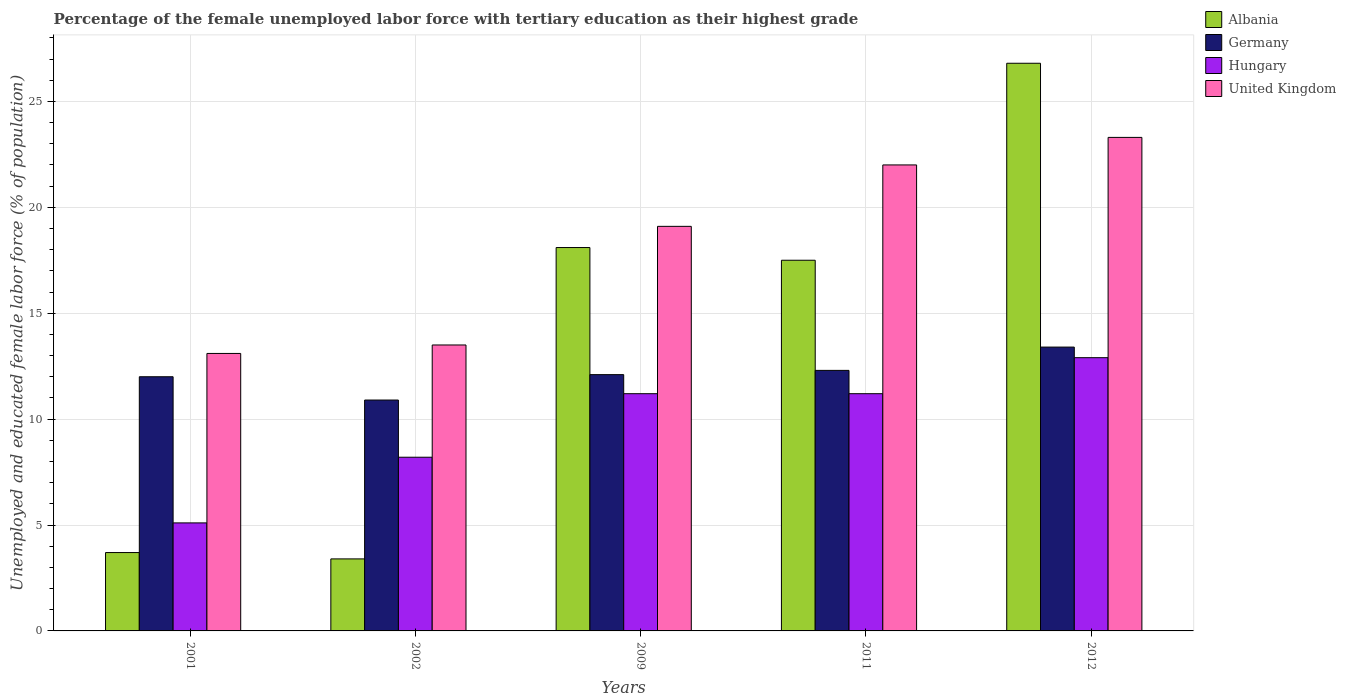How many different coloured bars are there?
Give a very brief answer. 4. How many groups of bars are there?
Your response must be concise. 5. Are the number of bars per tick equal to the number of legend labels?
Keep it short and to the point. Yes. Are the number of bars on each tick of the X-axis equal?
Your response must be concise. Yes. How many bars are there on the 3rd tick from the left?
Your answer should be compact. 4. How many bars are there on the 1st tick from the right?
Offer a terse response. 4. In how many cases, is the number of bars for a given year not equal to the number of legend labels?
Your answer should be very brief. 0. What is the percentage of the unemployed female labor force with tertiary education in Germany in 2001?
Ensure brevity in your answer.  12. Across all years, what is the maximum percentage of the unemployed female labor force with tertiary education in Germany?
Your answer should be very brief. 13.4. Across all years, what is the minimum percentage of the unemployed female labor force with tertiary education in Hungary?
Provide a succinct answer. 5.1. In which year was the percentage of the unemployed female labor force with tertiary education in Albania minimum?
Make the answer very short. 2002. What is the total percentage of the unemployed female labor force with tertiary education in United Kingdom in the graph?
Provide a succinct answer. 91. What is the difference between the percentage of the unemployed female labor force with tertiary education in Hungary in 2011 and that in 2012?
Offer a very short reply. -1.7. What is the difference between the percentage of the unemployed female labor force with tertiary education in Hungary in 2011 and the percentage of the unemployed female labor force with tertiary education in Germany in 2001?
Keep it short and to the point. -0.8. What is the average percentage of the unemployed female labor force with tertiary education in Hungary per year?
Provide a succinct answer. 9.72. In the year 2011, what is the difference between the percentage of the unemployed female labor force with tertiary education in Hungary and percentage of the unemployed female labor force with tertiary education in United Kingdom?
Offer a terse response. -10.8. What is the ratio of the percentage of the unemployed female labor force with tertiary education in United Kingdom in 2009 to that in 2012?
Your answer should be very brief. 0.82. Is the difference between the percentage of the unemployed female labor force with tertiary education in Hungary in 2001 and 2009 greater than the difference between the percentage of the unemployed female labor force with tertiary education in United Kingdom in 2001 and 2009?
Your answer should be compact. No. What is the difference between the highest and the second highest percentage of the unemployed female labor force with tertiary education in Hungary?
Make the answer very short. 1.7. What is the difference between the highest and the lowest percentage of the unemployed female labor force with tertiary education in Hungary?
Your answer should be very brief. 7.8. Is the sum of the percentage of the unemployed female labor force with tertiary education in Germany in 2001 and 2012 greater than the maximum percentage of the unemployed female labor force with tertiary education in United Kingdom across all years?
Your answer should be very brief. Yes. Is it the case that in every year, the sum of the percentage of the unemployed female labor force with tertiary education in Albania and percentage of the unemployed female labor force with tertiary education in Hungary is greater than the sum of percentage of the unemployed female labor force with tertiary education in United Kingdom and percentage of the unemployed female labor force with tertiary education in Germany?
Provide a succinct answer. No. What does the 3rd bar from the left in 2012 represents?
Keep it short and to the point. Hungary. What does the 2nd bar from the right in 2002 represents?
Offer a very short reply. Hungary. Are the values on the major ticks of Y-axis written in scientific E-notation?
Give a very brief answer. No. Where does the legend appear in the graph?
Keep it short and to the point. Top right. How many legend labels are there?
Provide a succinct answer. 4. What is the title of the graph?
Provide a succinct answer. Percentage of the female unemployed labor force with tertiary education as their highest grade. Does "Netherlands" appear as one of the legend labels in the graph?
Keep it short and to the point. No. What is the label or title of the Y-axis?
Give a very brief answer. Unemployed and educated female labor force (% of population). What is the Unemployed and educated female labor force (% of population) of Albania in 2001?
Ensure brevity in your answer.  3.7. What is the Unemployed and educated female labor force (% of population) of Germany in 2001?
Keep it short and to the point. 12. What is the Unemployed and educated female labor force (% of population) of Hungary in 2001?
Give a very brief answer. 5.1. What is the Unemployed and educated female labor force (% of population) in United Kingdom in 2001?
Provide a succinct answer. 13.1. What is the Unemployed and educated female labor force (% of population) of Albania in 2002?
Keep it short and to the point. 3.4. What is the Unemployed and educated female labor force (% of population) of Germany in 2002?
Offer a terse response. 10.9. What is the Unemployed and educated female labor force (% of population) of Hungary in 2002?
Provide a short and direct response. 8.2. What is the Unemployed and educated female labor force (% of population) in Albania in 2009?
Your answer should be compact. 18.1. What is the Unemployed and educated female labor force (% of population) of Germany in 2009?
Make the answer very short. 12.1. What is the Unemployed and educated female labor force (% of population) in Hungary in 2009?
Your answer should be compact. 11.2. What is the Unemployed and educated female labor force (% of population) in United Kingdom in 2009?
Your response must be concise. 19.1. What is the Unemployed and educated female labor force (% of population) of Germany in 2011?
Your response must be concise. 12.3. What is the Unemployed and educated female labor force (% of population) of Hungary in 2011?
Keep it short and to the point. 11.2. What is the Unemployed and educated female labor force (% of population) of United Kingdom in 2011?
Your response must be concise. 22. What is the Unemployed and educated female labor force (% of population) in Albania in 2012?
Provide a short and direct response. 26.8. What is the Unemployed and educated female labor force (% of population) of Germany in 2012?
Offer a very short reply. 13.4. What is the Unemployed and educated female labor force (% of population) of Hungary in 2012?
Your answer should be compact. 12.9. What is the Unemployed and educated female labor force (% of population) of United Kingdom in 2012?
Your response must be concise. 23.3. Across all years, what is the maximum Unemployed and educated female labor force (% of population) in Albania?
Ensure brevity in your answer.  26.8. Across all years, what is the maximum Unemployed and educated female labor force (% of population) in Germany?
Offer a very short reply. 13.4. Across all years, what is the maximum Unemployed and educated female labor force (% of population) in Hungary?
Offer a very short reply. 12.9. Across all years, what is the maximum Unemployed and educated female labor force (% of population) in United Kingdom?
Provide a short and direct response. 23.3. Across all years, what is the minimum Unemployed and educated female labor force (% of population) in Albania?
Ensure brevity in your answer.  3.4. Across all years, what is the minimum Unemployed and educated female labor force (% of population) in Germany?
Ensure brevity in your answer.  10.9. Across all years, what is the minimum Unemployed and educated female labor force (% of population) of Hungary?
Offer a terse response. 5.1. Across all years, what is the minimum Unemployed and educated female labor force (% of population) in United Kingdom?
Make the answer very short. 13.1. What is the total Unemployed and educated female labor force (% of population) in Albania in the graph?
Your answer should be very brief. 69.5. What is the total Unemployed and educated female labor force (% of population) in Germany in the graph?
Provide a short and direct response. 60.7. What is the total Unemployed and educated female labor force (% of population) in Hungary in the graph?
Make the answer very short. 48.6. What is the total Unemployed and educated female labor force (% of population) in United Kingdom in the graph?
Provide a short and direct response. 91. What is the difference between the Unemployed and educated female labor force (% of population) in Albania in 2001 and that in 2002?
Provide a succinct answer. 0.3. What is the difference between the Unemployed and educated female labor force (% of population) of Germany in 2001 and that in 2002?
Provide a succinct answer. 1.1. What is the difference between the Unemployed and educated female labor force (% of population) of United Kingdom in 2001 and that in 2002?
Give a very brief answer. -0.4. What is the difference between the Unemployed and educated female labor force (% of population) in Albania in 2001 and that in 2009?
Keep it short and to the point. -14.4. What is the difference between the Unemployed and educated female labor force (% of population) in Hungary in 2001 and that in 2009?
Ensure brevity in your answer.  -6.1. What is the difference between the Unemployed and educated female labor force (% of population) in United Kingdom in 2001 and that in 2009?
Ensure brevity in your answer.  -6. What is the difference between the Unemployed and educated female labor force (% of population) of Albania in 2001 and that in 2012?
Keep it short and to the point. -23.1. What is the difference between the Unemployed and educated female labor force (% of population) of Germany in 2001 and that in 2012?
Offer a very short reply. -1.4. What is the difference between the Unemployed and educated female labor force (% of population) of Albania in 2002 and that in 2009?
Ensure brevity in your answer.  -14.7. What is the difference between the Unemployed and educated female labor force (% of population) of Germany in 2002 and that in 2009?
Offer a very short reply. -1.2. What is the difference between the Unemployed and educated female labor force (% of population) of United Kingdom in 2002 and that in 2009?
Your response must be concise. -5.6. What is the difference between the Unemployed and educated female labor force (% of population) in Albania in 2002 and that in 2011?
Ensure brevity in your answer.  -14.1. What is the difference between the Unemployed and educated female labor force (% of population) in Hungary in 2002 and that in 2011?
Offer a terse response. -3. What is the difference between the Unemployed and educated female labor force (% of population) of United Kingdom in 2002 and that in 2011?
Your answer should be very brief. -8.5. What is the difference between the Unemployed and educated female labor force (% of population) in Albania in 2002 and that in 2012?
Give a very brief answer. -23.4. What is the difference between the Unemployed and educated female labor force (% of population) of Hungary in 2009 and that in 2011?
Make the answer very short. 0. What is the difference between the Unemployed and educated female labor force (% of population) in United Kingdom in 2009 and that in 2011?
Provide a succinct answer. -2.9. What is the difference between the Unemployed and educated female labor force (% of population) of Albania in 2009 and that in 2012?
Your answer should be compact. -8.7. What is the difference between the Unemployed and educated female labor force (% of population) of Germany in 2009 and that in 2012?
Keep it short and to the point. -1.3. What is the difference between the Unemployed and educated female labor force (% of population) in Hungary in 2009 and that in 2012?
Keep it short and to the point. -1.7. What is the difference between the Unemployed and educated female labor force (% of population) in Albania in 2011 and that in 2012?
Your response must be concise. -9.3. What is the difference between the Unemployed and educated female labor force (% of population) in United Kingdom in 2011 and that in 2012?
Offer a terse response. -1.3. What is the difference between the Unemployed and educated female labor force (% of population) of Albania in 2001 and the Unemployed and educated female labor force (% of population) of Hungary in 2002?
Offer a very short reply. -4.5. What is the difference between the Unemployed and educated female labor force (% of population) in Albania in 2001 and the Unemployed and educated female labor force (% of population) in United Kingdom in 2002?
Your answer should be compact. -9.8. What is the difference between the Unemployed and educated female labor force (% of population) of Germany in 2001 and the Unemployed and educated female labor force (% of population) of Hungary in 2002?
Provide a succinct answer. 3.8. What is the difference between the Unemployed and educated female labor force (% of population) in Germany in 2001 and the Unemployed and educated female labor force (% of population) in United Kingdom in 2002?
Offer a very short reply. -1.5. What is the difference between the Unemployed and educated female labor force (% of population) of Albania in 2001 and the Unemployed and educated female labor force (% of population) of United Kingdom in 2009?
Provide a short and direct response. -15.4. What is the difference between the Unemployed and educated female labor force (% of population) of Hungary in 2001 and the Unemployed and educated female labor force (% of population) of United Kingdom in 2009?
Your answer should be compact. -14. What is the difference between the Unemployed and educated female labor force (% of population) of Albania in 2001 and the Unemployed and educated female labor force (% of population) of Germany in 2011?
Your answer should be compact. -8.6. What is the difference between the Unemployed and educated female labor force (% of population) of Albania in 2001 and the Unemployed and educated female labor force (% of population) of United Kingdom in 2011?
Your answer should be very brief. -18.3. What is the difference between the Unemployed and educated female labor force (% of population) in Germany in 2001 and the Unemployed and educated female labor force (% of population) in United Kingdom in 2011?
Make the answer very short. -10. What is the difference between the Unemployed and educated female labor force (% of population) of Hungary in 2001 and the Unemployed and educated female labor force (% of population) of United Kingdom in 2011?
Your response must be concise. -16.9. What is the difference between the Unemployed and educated female labor force (% of population) of Albania in 2001 and the Unemployed and educated female labor force (% of population) of Hungary in 2012?
Your answer should be compact. -9.2. What is the difference between the Unemployed and educated female labor force (% of population) of Albania in 2001 and the Unemployed and educated female labor force (% of population) of United Kingdom in 2012?
Your answer should be very brief. -19.6. What is the difference between the Unemployed and educated female labor force (% of population) in Germany in 2001 and the Unemployed and educated female labor force (% of population) in United Kingdom in 2012?
Provide a short and direct response. -11.3. What is the difference between the Unemployed and educated female labor force (% of population) in Hungary in 2001 and the Unemployed and educated female labor force (% of population) in United Kingdom in 2012?
Your answer should be very brief. -18.2. What is the difference between the Unemployed and educated female labor force (% of population) of Albania in 2002 and the Unemployed and educated female labor force (% of population) of United Kingdom in 2009?
Provide a short and direct response. -15.7. What is the difference between the Unemployed and educated female labor force (% of population) of Germany in 2002 and the Unemployed and educated female labor force (% of population) of Hungary in 2009?
Make the answer very short. -0.3. What is the difference between the Unemployed and educated female labor force (% of population) of Germany in 2002 and the Unemployed and educated female labor force (% of population) of United Kingdom in 2009?
Make the answer very short. -8.2. What is the difference between the Unemployed and educated female labor force (% of population) of Albania in 2002 and the Unemployed and educated female labor force (% of population) of Germany in 2011?
Offer a terse response. -8.9. What is the difference between the Unemployed and educated female labor force (% of population) in Albania in 2002 and the Unemployed and educated female labor force (% of population) in United Kingdom in 2011?
Give a very brief answer. -18.6. What is the difference between the Unemployed and educated female labor force (% of population) in Germany in 2002 and the Unemployed and educated female labor force (% of population) in Hungary in 2011?
Keep it short and to the point. -0.3. What is the difference between the Unemployed and educated female labor force (% of population) of Germany in 2002 and the Unemployed and educated female labor force (% of population) of United Kingdom in 2011?
Give a very brief answer. -11.1. What is the difference between the Unemployed and educated female labor force (% of population) in Albania in 2002 and the Unemployed and educated female labor force (% of population) in Germany in 2012?
Offer a terse response. -10. What is the difference between the Unemployed and educated female labor force (% of population) of Albania in 2002 and the Unemployed and educated female labor force (% of population) of United Kingdom in 2012?
Provide a succinct answer. -19.9. What is the difference between the Unemployed and educated female labor force (% of population) in Germany in 2002 and the Unemployed and educated female labor force (% of population) in Hungary in 2012?
Keep it short and to the point. -2. What is the difference between the Unemployed and educated female labor force (% of population) of Germany in 2002 and the Unemployed and educated female labor force (% of population) of United Kingdom in 2012?
Your answer should be compact. -12.4. What is the difference between the Unemployed and educated female labor force (% of population) of Hungary in 2002 and the Unemployed and educated female labor force (% of population) of United Kingdom in 2012?
Offer a very short reply. -15.1. What is the difference between the Unemployed and educated female labor force (% of population) of Albania in 2009 and the Unemployed and educated female labor force (% of population) of Germany in 2011?
Keep it short and to the point. 5.8. What is the difference between the Unemployed and educated female labor force (% of population) of Albania in 2009 and the Unemployed and educated female labor force (% of population) of Hungary in 2011?
Ensure brevity in your answer.  6.9. What is the difference between the Unemployed and educated female labor force (% of population) in Albania in 2009 and the Unemployed and educated female labor force (% of population) in United Kingdom in 2011?
Provide a short and direct response. -3.9. What is the difference between the Unemployed and educated female labor force (% of population) of Albania in 2009 and the Unemployed and educated female labor force (% of population) of Germany in 2012?
Your answer should be very brief. 4.7. What is the difference between the Unemployed and educated female labor force (% of population) of Albania in 2009 and the Unemployed and educated female labor force (% of population) of Hungary in 2012?
Provide a succinct answer. 5.2. What is the difference between the Unemployed and educated female labor force (% of population) in Germany in 2011 and the Unemployed and educated female labor force (% of population) in Hungary in 2012?
Make the answer very short. -0.6. What is the difference between the Unemployed and educated female labor force (% of population) of Germany in 2011 and the Unemployed and educated female labor force (% of population) of United Kingdom in 2012?
Offer a terse response. -11. What is the difference between the Unemployed and educated female labor force (% of population) in Hungary in 2011 and the Unemployed and educated female labor force (% of population) in United Kingdom in 2012?
Provide a short and direct response. -12.1. What is the average Unemployed and educated female labor force (% of population) of Germany per year?
Your answer should be compact. 12.14. What is the average Unemployed and educated female labor force (% of population) of Hungary per year?
Make the answer very short. 9.72. What is the average Unemployed and educated female labor force (% of population) of United Kingdom per year?
Provide a succinct answer. 18.2. In the year 2001, what is the difference between the Unemployed and educated female labor force (% of population) in Albania and Unemployed and educated female labor force (% of population) in Hungary?
Your response must be concise. -1.4. In the year 2001, what is the difference between the Unemployed and educated female labor force (% of population) in Albania and Unemployed and educated female labor force (% of population) in United Kingdom?
Offer a very short reply. -9.4. In the year 2001, what is the difference between the Unemployed and educated female labor force (% of population) of Germany and Unemployed and educated female labor force (% of population) of Hungary?
Your answer should be very brief. 6.9. In the year 2001, what is the difference between the Unemployed and educated female labor force (% of population) of Germany and Unemployed and educated female labor force (% of population) of United Kingdom?
Your response must be concise. -1.1. In the year 2002, what is the difference between the Unemployed and educated female labor force (% of population) in Albania and Unemployed and educated female labor force (% of population) in Germany?
Your answer should be compact. -7.5. In the year 2002, what is the difference between the Unemployed and educated female labor force (% of population) in Albania and Unemployed and educated female labor force (% of population) in Hungary?
Provide a short and direct response. -4.8. In the year 2002, what is the difference between the Unemployed and educated female labor force (% of population) of Germany and Unemployed and educated female labor force (% of population) of Hungary?
Your answer should be very brief. 2.7. In the year 2002, what is the difference between the Unemployed and educated female labor force (% of population) of Germany and Unemployed and educated female labor force (% of population) of United Kingdom?
Your answer should be very brief. -2.6. In the year 2009, what is the difference between the Unemployed and educated female labor force (% of population) of Albania and Unemployed and educated female labor force (% of population) of Hungary?
Ensure brevity in your answer.  6.9. In the year 2009, what is the difference between the Unemployed and educated female labor force (% of population) of Germany and Unemployed and educated female labor force (% of population) of United Kingdom?
Your answer should be compact. -7. In the year 2009, what is the difference between the Unemployed and educated female labor force (% of population) in Hungary and Unemployed and educated female labor force (% of population) in United Kingdom?
Offer a very short reply. -7.9. In the year 2011, what is the difference between the Unemployed and educated female labor force (% of population) in Albania and Unemployed and educated female labor force (% of population) in Hungary?
Give a very brief answer. 6.3. In the year 2012, what is the difference between the Unemployed and educated female labor force (% of population) in Albania and Unemployed and educated female labor force (% of population) in Germany?
Keep it short and to the point. 13.4. In the year 2012, what is the difference between the Unemployed and educated female labor force (% of population) in Albania and Unemployed and educated female labor force (% of population) in United Kingdom?
Make the answer very short. 3.5. In the year 2012, what is the difference between the Unemployed and educated female labor force (% of population) of Germany and Unemployed and educated female labor force (% of population) of Hungary?
Make the answer very short. 0.5. In the year 2012, what is the difference between the Unemployed and educated female labor force (% of population) in Hungary and Unemployed and educated female labor force (% of population) in United Kingdom?
Offer a terse response. -10.4. What is the ratio of the Unemployed and educated female labor force (% of population) in Albania in 2001 to that in 2002?
Your response must be concise. 1.09. What is the ratio of the Unemployed and educated female labor force (% of population) of Germany in 2001 to that in 2002?
Your answer should be compact. 1.1. What is the ratio of the Unemployed and educated female labor force (% of population) in Hungary in 2001 to that in 2002?
Provide a short and direct response. 0.62. What is the ratio of the Unemployed and educated female labor force (% of population) in United Kingdom in 2001 to that in 2002?
Offer a terse response. 0.97. What is the ratio of the Unemployed and educated female labor force (% of population) in Albania in 2001 to that in 2009?
Provide a succinct answer. 0.2. What is the ratio of the Unemployed and educated female labor force (% of population) in Hungary in 2001 to that in 2009?
Your answer should be very brief. 0.46. What is the ratio of the Unemployed and educated female labor force (% of population) of United Kingdom in 2001 to that in 2009?
Your response must be concise. 0.69. What is the ratio of the Unemployed and educated female labor force (% of population) in Albania in 2001 to that in 2011?
Provide a succinct answer. 0.21. What is the ratio of the Unemployed and educated female labor force (% of population) in Germany in 2001 to that in 2011?
Make the answer very short. 0.98. What is the ratio of the Unemployed and educated female labor force (% of population) of Hungary in 2001 to that in 2011?
Ensure brevity in your answer.  0.46. What is the ratio of the Unemployed and educated female labor force (% of population) in United Kingdom in 2001 to that in 2011?
Offer a very short reply. 0.6. What is the ratio of the Unemployed and educated female labor force (% of population) of Albania in 2001 to that in 2012?
Your response must be concise. 0.14. What is the ratio of the Unemployed and educated female labor force (% of population) in Germany in 2001 to that in 2012?
Your answer should be compact. 0.9. What is the ratio of the Unemployed and educated female labor force (% of population) in Hungary in 2001 to that in 2012?
Provide a short and direct response. 0.4. What is the ratio of the Unemployed and educated female labor force (% of population) in United Kingdom in 2001 to that in 2012?
Provide a succinct answer. 0.56. What is the ratio of the Unemployed and educated female labor force (% of population) of Albania in 2002 to that in 2009?
Offer a very short reply. 0.19. What is the ratio of the Unemployed and educated female labor force (% of population) of Germany in 2002 to that in 2009?
Offer a terse response. 0.9. What is the ratio of the Unemployed and educated female labor force (% of population) in Hungary in 2002 to that in 2009?
Keep it short and to the point. 0.73. What is the ratio of the Unemployed and educated female labor force (% of population) of United Kingdom in 2002 to that in 2009?
Your answer should be compact. 0.71. What is the ratio of the Unemployed and educated female labor force (% of population) in Albania in 2002 to that in 2011?
Your response must be concise. 0.19. What is the ratio of the Unemployed and educated female labor force (% of population) in Germany in 2002 to that in 2011?
Provide a succinct answer. 0.89. What is the ratio of the Unemployed and educated female labor force (% of population) in Hungary in 2002 to that in 2011?
Offer a terse response. 0.73. What is the ratio of the Unemployed and educated female labor force (% of population) in United Kingdom in 2002 to that in 2011?
Keep it short and to the point. 0.61. What is the ratio of the Unemployed and educated female labor force (% of population) in Albania in 2002 to that in 2012?
Your answer should be compact. 0.13. What is the ratio of the Unemployed and educated female labor force (% of population) in Germany in 2002 to that in 2012?
Your answer should be very brief. 0.81. What is the ratio of the Unemployed and educated female labor force (% of population) of Hungary in 2002 to that in 2012?
Give a very brief answer. 0.64. What is the ratio of the Unemployed and educated female labor force (% of population) of United Kingdom in 2002 to that in 2012?
Give a very brief answer. 0.58. What is the ratio of the Unemployed and educated female labor force (% of population) in Albania in 2009 to that in 2011?
Provide a short and direct response. 1.03. What is the ratio of the Unemployed and educated female labor force (% of population) of Germany in 2009 to that in 2011?
Offer a very short reply. 0.98. What is the ratio of the Unemployed and educated female labor force (% of population) in United Kingdom in 2009 to that in 2011?
Your answer should be compact. 0.87. What is the ratio of the Unemployed and educated female labor force (% of population) of Albania in 2009 to that in 2012?
Offer a very short reply. 0.68. What is the ratio of the Unemployed and educated female labor force (% of population) in Germany in 2009 to that in 2012?
Your answer should be very brief. 0.9. What is the ratio of the Unemployed and educated female labor force (% of population) of Hungary in 2009 to that in 2012?
Keep it short and to the point. 0.87. What is the ratio of the Unemployed and educated female labor force (% of population) in United Kingdom in 2009 to that in 2012?
Give a very brief answer. 0.82. What is the ratio of the Unemployed and educated female labor force (% of population) in Albania in 2011 to that in 2012?
Offer a very short reply. 0.65. What is the ratio of the Unemployed and educated female labor force (% of population) of Germany in 2011 to that in 2012?
Provide a short and direct response. 0.92. What is the ratio of the Unemployed and educated female labor force (% of population) of Hungary in 2011 to that in 2012?
Provide a succinct answer. 0.87. What is the ratio of the Unemployed and educated female labor force (% of population) in United Kingdom in 2011 to that in 2012?
Provide a succinct answer. 0.94. What is the difference between the highest and the second highest Unemployed and educated female labor force (% of population) of United Kingdom?
Keep it short and to the point. 1.3. What is the difference between the highest and the lowest Unemployed and educated female labor force (% of population) of Albania?
Your response must be concise. 23.4. What is the difference between the highest and the lowest Unemployed and educated female labor force (% of population) in Germany?
Offer a very short reply. 2.5. What is the difference between the highest and the lowest Unemployed and educated female labor force (% of population) in Hungary?
Make the answer very short. 7.8. What is the difference between the highest and the lowest Unemployed and educated female labor force (% of population) in United Kingdom?
Give a very brief answer. 10.2. 